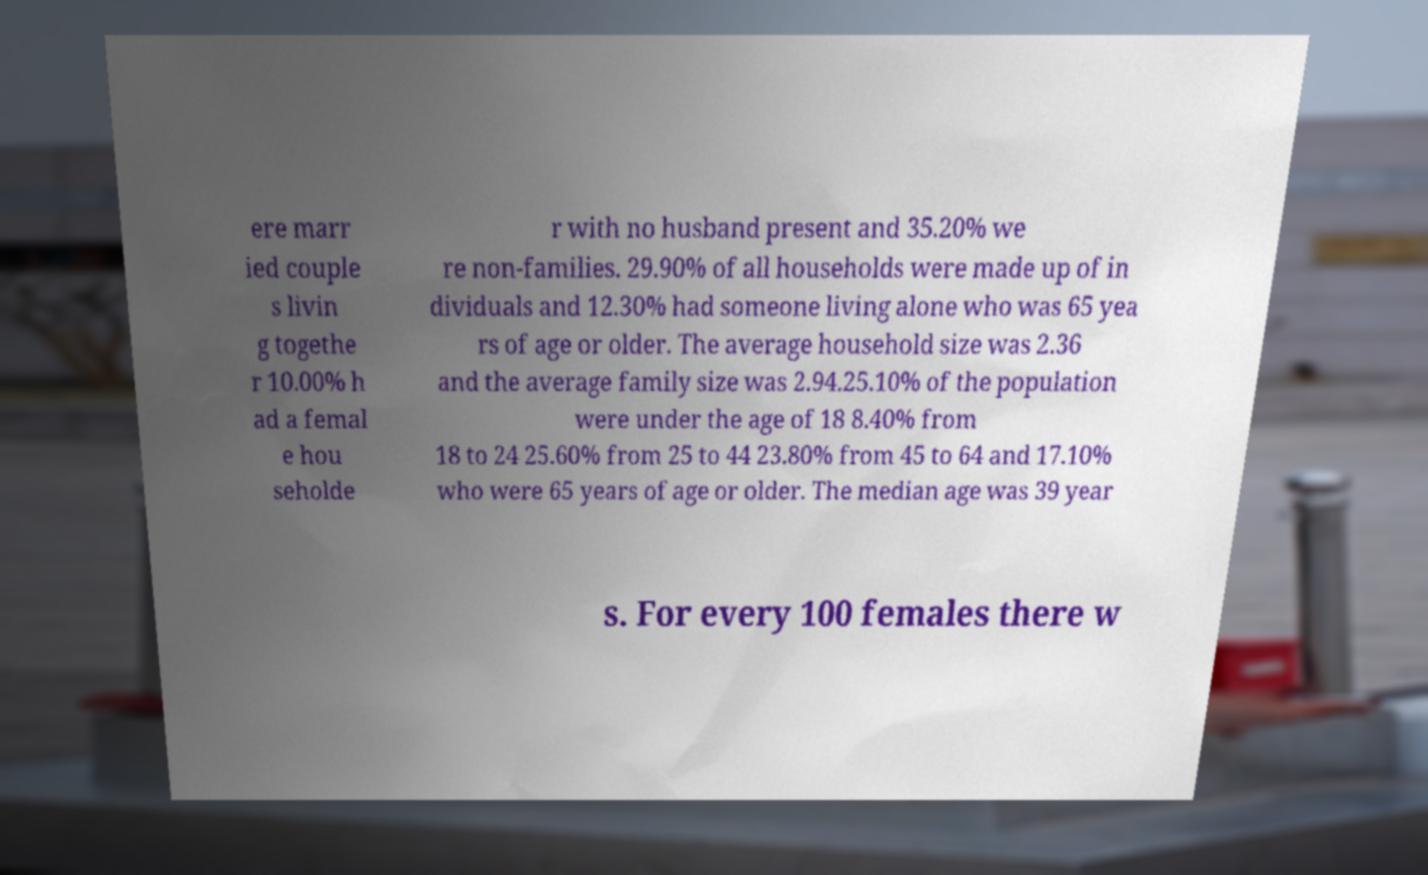Can you read and provide the text displayed in the image?This photo seems to have some interesting text. Can you extract and type it out for me? ere marr ied couple s livin g togethe r 10.00% h ad a femal e hou seholde r with no husband present and 35.20% we re non-families. 29.90% of all households were made up of in dividuals and 12.30% had someone living alone who was 65 yea rs of age or older. The average household size was 2.36 and the average family size was 2.94.25.10% of the population were under the age of 18 8.40% from 18 to 24 25.60% from 25 to 44 23.80% from 45 to 64 and 17.10% who were 65 years of age or older. The median age was 39 year s. For every 100 females there w 